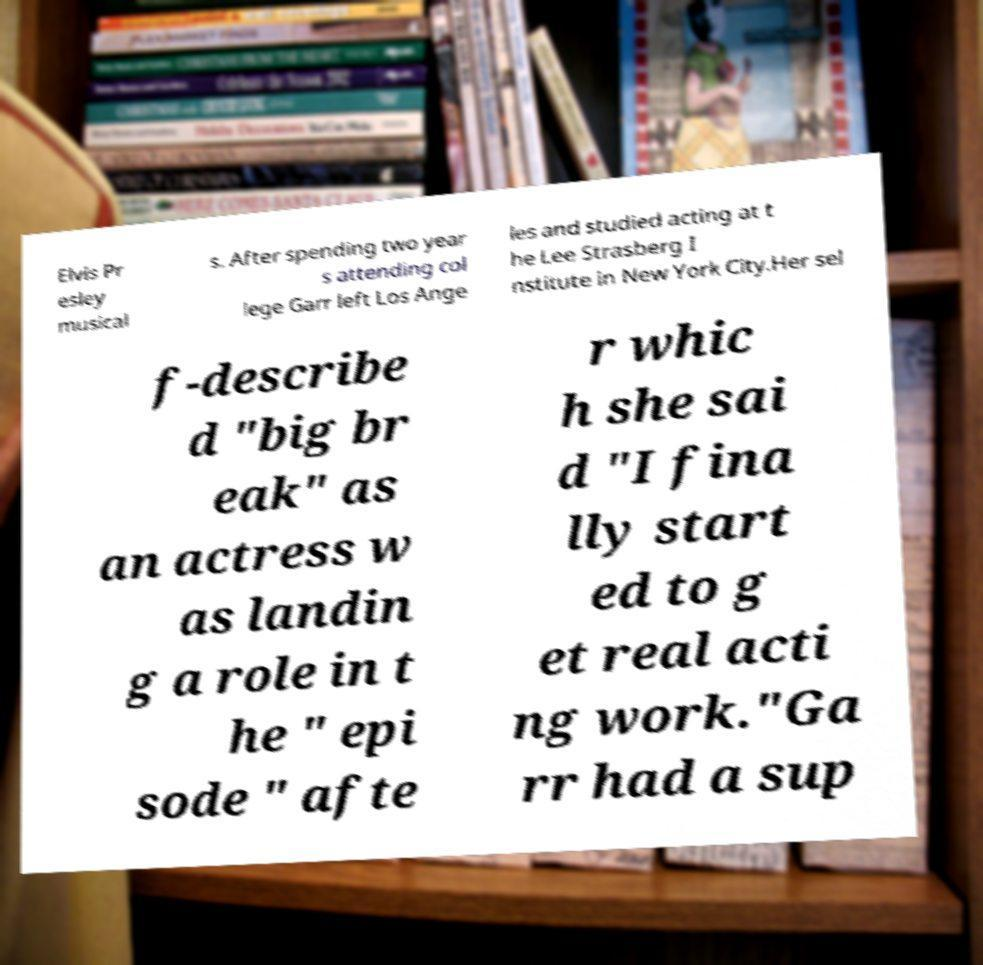Can you accurately transcribe the text from the provided image for me? Elvis Pr esley musical s. After spending two year s attending col lege Garr left Los Ange les and studied acting at t he Lee Strasberg I nstitute in New York City.Her sel f-describe d "big br eak" as an actress w as landin g a role in t he " epi sode " afte r whic h she sai d "I fina lly start ed to g et real acti ng work."Ga rr had a sup 